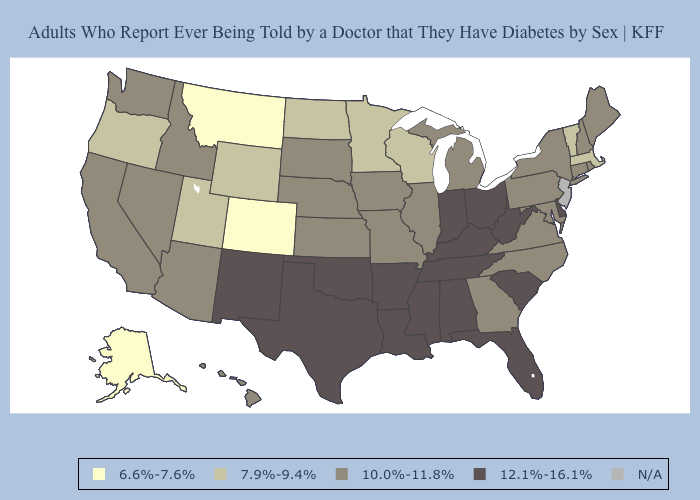Which states have the highest value in the USA?
Quick response, please. Alabama, Arkansas, Delaware, Florida, Indiana, Kentucky, Louisiana, Mississippi, New Mexico, Ohio, Oklahoma, South Carolina, Tennessee, Texas, West Virginia. What is the value of Maine?
Give a very brief answer. 10.0%-11.8%. Does New Hampshire have the lowest value in the Northeast?
Give a very brief answer. No. How many symbols are there in the legend?
Be succinct. 5. Name the states that have a value in the range 12.1%-16.1%?
Answer briefly. Alabama, Arkansas, Delaware, Florida, Indiana, Kentucky, Louisiana, Mississippi, New Mexico, Ohio, Oklahoma, South Carolina, Tennessee, Texas, West Virginia. What is the highest value in the West ?
Keep it brief. 12.1%-16.1%. Name the states that have a value in the range 7.9%-9.4%?
Give a very brief answer. Massachusetts, Minnesota, North Dakota, Oregon, Utah, Vermont, Wisconsin, Wyoming. How many symbols are there in the legend?
Keep it brief. 5. Does North Carolina have the highest value in the South?
Short answer required. No. Name the states that have a value in the range 7.9%-9.4%?
Short answer required. Massachusetts, Minnesota, North Dakota, Oregon, Utah, Vermont, Wisconsin, Wyoming. 